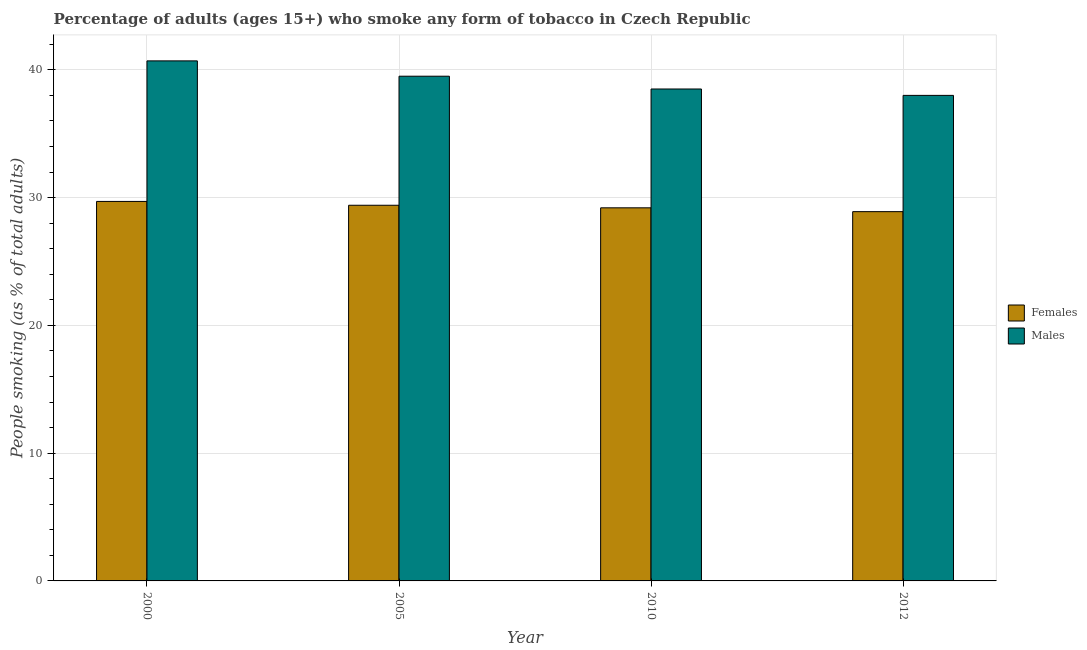Are the number of bars per tick equal to the number of legend labels?
Provide a succinct answer. Yes. How many bars are there on the 4th tick from the left?
Give a very brief answer. 2. What is the label of the 2nd group of bars from the left?
Give a very brief answer. 2005. In how many cases, is the number of bars for a given year not equal to the number of legend labels?
Offer a very short reply. 0. What is the percentage of females who smoke in 2010?
Ensure brevity in your answer.  29.2. Across all years, what is the maximum percentage of males who smoke?
Ensure brevity in your answer.  40.7. What is the total percentage of males who smoke in the graph?
Provide a succinct answer. 156.7. What is the difference between the percentage of males who smoke in 2000 and that in 2010?
Offer a very short reply. 2.2. What is the difference between the percentage of males who smoke in 2010 and the percentage of females who smoke in 2000?
Offer a terse response. -2.2. What is the average percentage of females who smoke per year?
Make the answer very short. 29.3. In the year 2005, what is the difference between the percentage of males who smoke and percentage of females who smoke?
Provide a succinct answer. 0. In how many years, is the percentage of males who smoke greater than 12 %?
Offer a very short reply. 4. What is the ratio of the percentage of females who smoke in 2000 to that in 2005?
Offer a terse response. 1.01. Is the percentage of females who smoke in 2000 less than that in 2012?
Your answer should be compact. No. Is the difference between the percentage of males who smoke in 2000 and 2010 greater than the difference between the percentage of females who smoke in 2000 and 2010?
Provide a succinct answer. No. What is the difference between the highest and the second highest percentage of females who smoke?
Provide a succinct answer. 0.3. What is the difference between the highest and the lowest percentage of males who smoke?
Keep it short and to the point. 2.7. In how many years, is the percentage of males who smoke greater than the average percentage of males who smoke taken over all years?
Provide a succinct answer. 2. Is the sum of the percentage of males who smoke in 2005 and 2010 greater than the maximum percentage of females who smoke across all years?
Ensure brevity in your answer.  Yes. What does the 2nd bar from the left in 2010 represents?
Offer a terse response. Males. What does the 1st bar from the right in 2000 represents?
Keep it short and to the point. Males. What is the difference between two consecutive major ticks on the Y-axis?
Your response must be concise. 10. How many legend labels are there?
Your response must be concise. 2. What is the title of the graph?
Give a very brief answer. Percentage of adults (ages 15+) who smoke any form of tobacco in Czech Republic. Does "Travel Items" appear as one of the legend labels in the graph?
Keep it short and to the point. No. What is the label or title of the Y-axis?
Make the answer very short. People smoking (as % of total adults). What is the People smoking (as % of total adults) of Females in 2000?
Offer a very short reply. 29.7. What is the People smoking (as % of total adults) of Males in 2000?
Keep it short and to the point. 40.7. What is the People smoking (as % of total adults) in Females in 2005?
Your answer should be very brief. 29.4. What is the People smoking (as % of total adults) in Males in 2005?
Make the answer very short. 39.5. What is the People smoking (as % of total adults) in Females in 2010?
Your response must be concise. 29.2. What is the People smoking (as % of total adults) of Males in 2010?
Provide a succinct answer. 38.5. What is the People smoking (as % of total adults) of Females in 2012?
Keep it short and to the point. 28.9. What is the People smoking (as % of total adults) of Males in 2012?
Give a very brief answer. 38. Across all years, what is the maximum People smoking (as % of total adults) in Females?
Provide a short and direct response. 29.7. Across all years, what is the maximum People smoking (as % of total adults) of Males?
Your response must be concise. 40.7. Across all years, what is the minimum People smoking (as % of total adults) in Females?
Offer a terse response. 28.9. What is the total People smoking (as % of total adults) of Females in the graph?
Provide a succinct answer. 117.2. What is the total People smoking (as % of total adults) in Males in the graph?
Ensure brevity in your answer.  156.7. What is the difference between the People smoking (as % of total adults) of Males in 2000 and that in 2005?
Keep it short and to the point. 1.2. What is the difference between the People smoking (as % of total adults) in Females in 2000 and that in 2010?
Your response must be concise. 0.5. What is the difference between the People smoking (as % of total adults) of Males in 2000 and that in 2010?
Give a very brief answer. 2.2. What is the difference between the People smoking (as % of total adults) of Females in 2000 and that in 2012?
Keep it short and to the point. 0.8. What is the difference between the People smoking (as % of total adults) in Females in 2005 and that in 2010?
Your answer should be compact. 0.2. What is the difference between the People smoking (as % of total adults) in Males in 2005 and that in 2010?
Your response must be concise. 1. What is the difference between the People smoking (as % of total adults) of Males in 2010 and that in 2012?
Your answer should be very brief. 0.5. What is the difference between the People smoking (as % of total adults) in Females in 2000 and the People smoking (as % of total adults) in Males in 2005?
Your answer should be very brief. -9.8. What is the difference between the People smoking (as % of total adults) of Females in 2000 and the People smoking (as % of total adults) of Males in 2010?
Offer a very short reply. -8.8. What is the difference between the People smoking (as % of total adults) of Females in 2000 and the People smoking (as % of total adults) of Males in 2012?
Offer a very short reply. -8.3. What is the difference between the People smoking (as % of total adults) in Females in 2010 and the People smoking (as % of total adults) in Males in 2012?
Your response must be concise. -8.8. What is the average People smoking (as % of total adults) of Females per year?
Ensure brevity in your answer.  29.3. What is the average People smoking (as % of total adults) in Males per year?
Provide a short and direct response. 39.17. In the year 2012, what is the difference between the People smoking (as % of total adults) of Females and People smoking (as % of total adults) of Males?
Provide a succinct answer. -9.1. What is the ratio of the People smoking (as % of total adults) in Females in 2000 to that in 2005?
Your answer should be compact. 1.01. What is the ratio of the People smoking (as % of total adults) of Males in 2000 to that in 2005?
Keep it short and to the point. 1.03. What is the ratio of the People smoking (as % of total adults) of Females in 2000 to that in 2010?
Ensure brevity in your answer.  1.02. What is the ratio of the People smoking (as % of total adults) in Males in 2000 to that in 2010?
Your response must be concise. 1.06. What is the ratio of the People smoking (as % of total adults) in Females in 2000 to that in 2012?
Give a very brief answer. 1.03. What is the ratio of the People smoking (as % of total adults) of Males in 2000 to that in 2012?
Ensure brevity in your answer.  1.07. What is the ratio of the People smoking (as % of total adults) in Females in 2005 to that in 2010?
Offer a terse response. 1.01. What is the ratio of the People smoking (as % of total adults) in Males in 2005 to that in 2010?
Give a very brief answer. 1.03. What is the ratio of the People smoking (as % of total adults) in Females in 2005 to that in 2012?
Provide a short and direct response. 1.02. What is the ratio of the People smoking (as % of total adults) in Males in 2005 to that in 2012?
Provide a short and direct response. 1.04. What is the ratio of the People smoking (as % of total adults) of Females in 2010 to that in 2012?
Offer a terse response. 1.01. What is the ratio of the People smoking (as % of total adults) in Males in 2010 to that in 2012?
Your answer should be compact. 1.01. What is the difference between the highest and the second highest People smoking (as % of total adults) in Females?
Your answer should be very brief. 0.3. What is the difference between the highest and the lowest People smoking (as % of total adults) of Females?
Your answer should be very brief. 0.8. What is the difference between the highest and the lowest People smoking (as % of total adults) of Males?
Give a very brief answer. 2.7. 